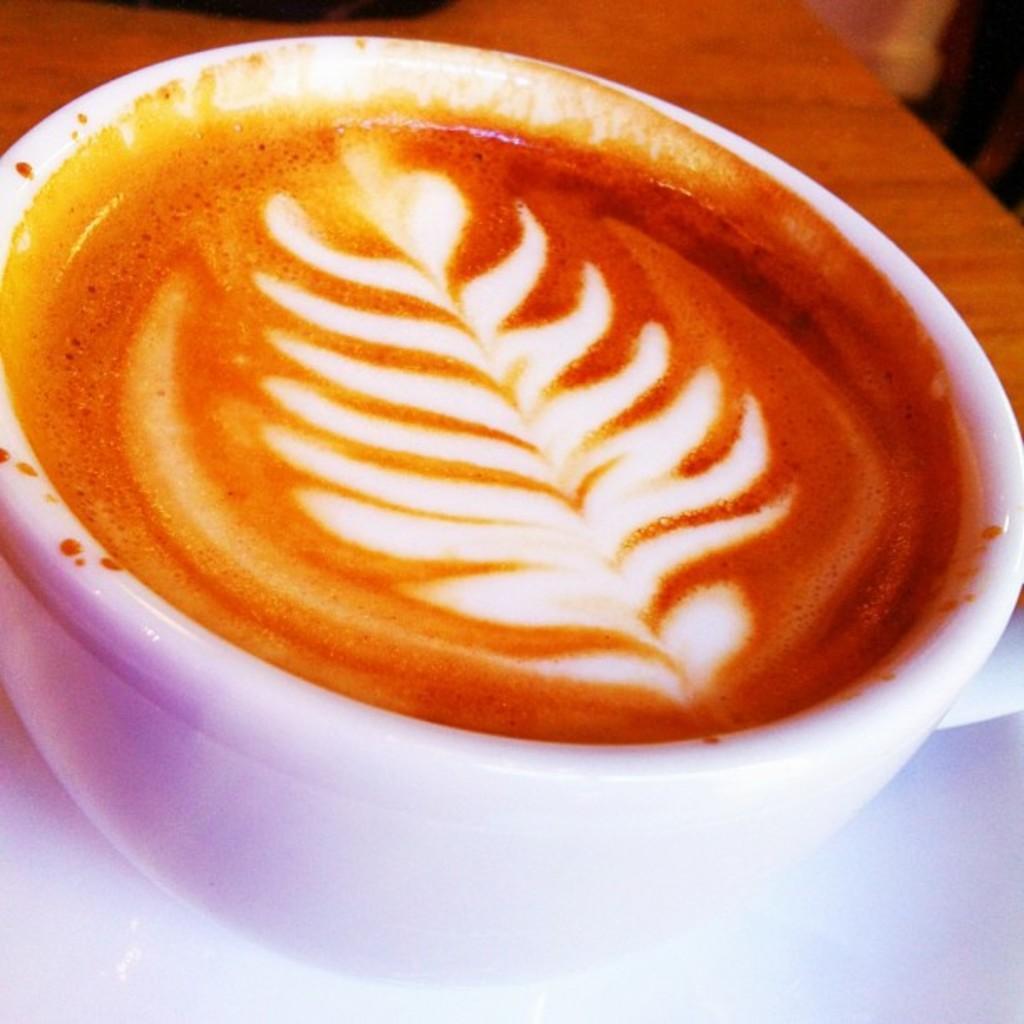Describe this image in one or two sentences. This is the cup, which is filled with coffee. I can see the latte art on the coffee. This looks like a wooden table. I think this is the saucer. 